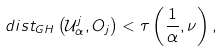<formula> <loc_0><loc_0><loc_500><loc_500>d i s t _ { G H } \left ( \mathcal { U } _ { \alpha } ^ { j } , O _ { j } \right ) < \tau \left ( \frac { 1 } { \alpha } , \nu \right ) ,</formula> 